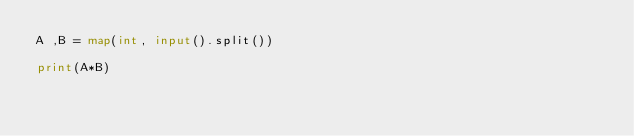Convert code to text. <code><loc_0><loc_0><loc_500><loc_500><_Python_>A ,B = map(int, input().split())

print(A*B)</code> 